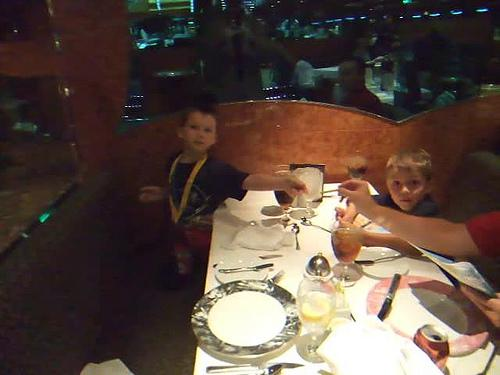Question: who is at the table?
Choices:
A. Mother and daughter.
B. Two kids and an adult.
C. Father and son.
D. A family of four.
Answer with the letter. Answer: B Question: how many people are there?
Choices:
A. Two.
B. Four.
C. Three.
D. Five.
Answer with the letter. Answer: C Question: when was this taken?
Choices:
A. During the day.
B. At lunch.
C. Meal time.
D. At dinner.
Answer with the letter. Answer: C Question: where are they sitting?
Choices:
A. In the grass.
B. By the table.
C. On a blanket.
D. At the beach.
Answer with the letter. Answer: B Question: why are there empty plates?
Choices:
A. They have finished eating.
B. They are waiting for cake.
C. There is no food to eat.
D. Haven't eaten dinner yet.
Answer with the letter. Answer: D Question: what meal is this?
Choices:
A. Dinner.
B. Lunch.
C. Breakfast.
D. Brunch.
Answer with the letter. Answer: A 